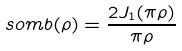<formula> <loc_0><loc_0><loc_500><loc_500>s o m b ( \rho ) = \frac { 2 J _ { 1 } ( \pi \rho ) } { \pi \rho }</formula> 